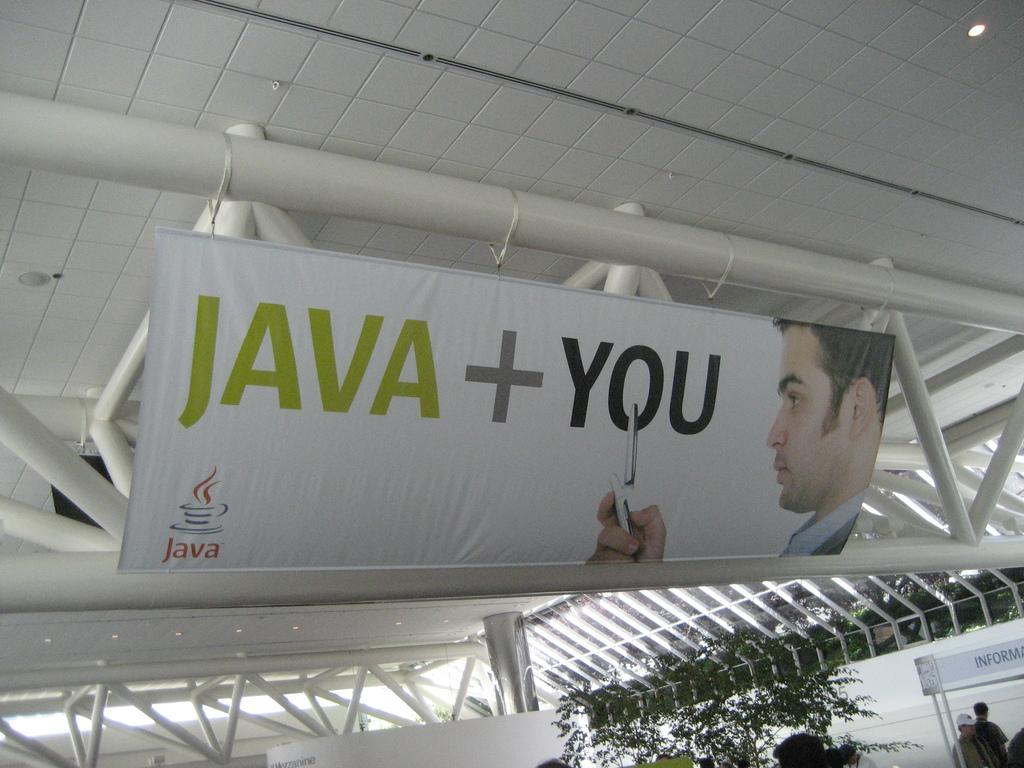What company is this for?
Offer a terse response. Java. What does the sign want to add to java?
Ensure brevity in your answer.  You. 